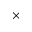<formula> <loc_0><loc_0><loc_500><loc_500>\times</formula> 